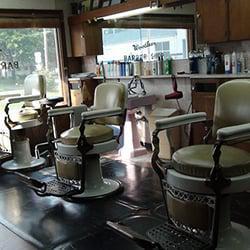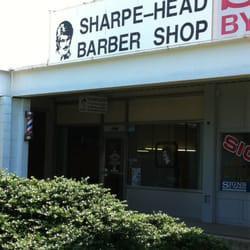The first image is the image on the left, the second image is the image on the right. For the images shown, is this caption "A woman is cutting a male's hair in at least one of the images." true? Answer yes or no. No. The first image is the image on the left, the second image is the image on the right. For the images displayed, is the sentence "One image is the outside of a barber shop and the other image is the inside of a barber shop." factually correct? Answer yes or no. Yes. 